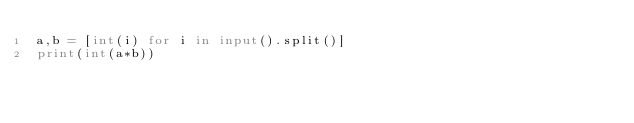<code> <loc_0><loc_0><loc_500><loc_500><_Python_>a,b = [int(i) for i in input().split()]
print(int(a*b))</code> 